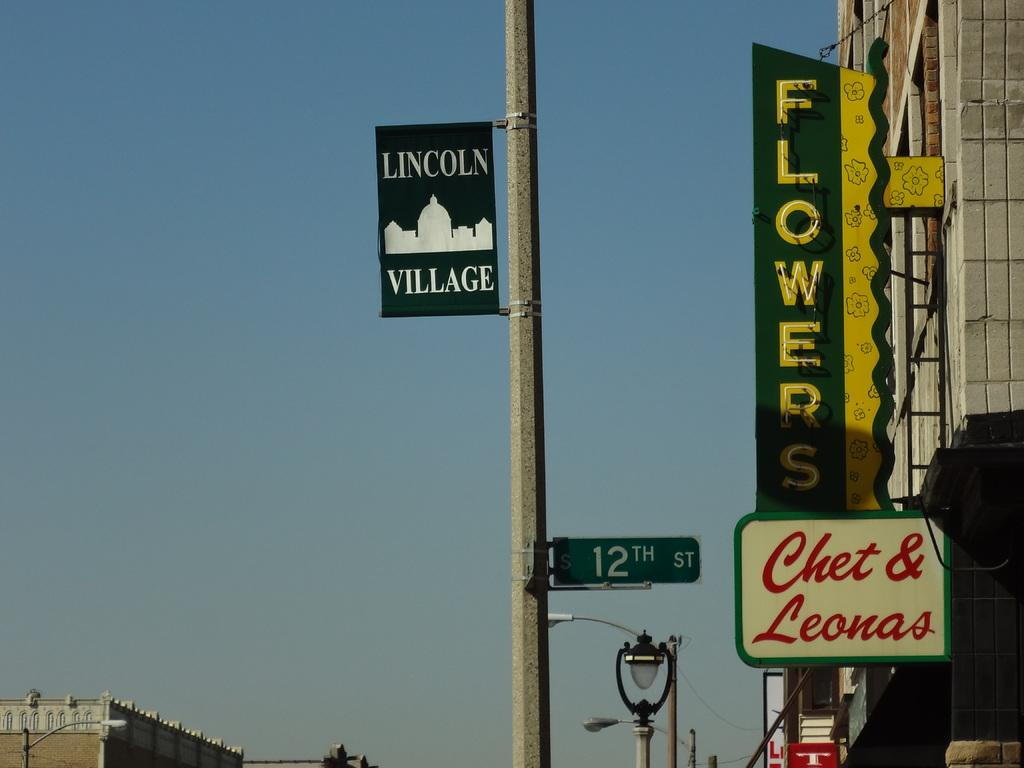<image>
Relay a brief, clear account of the picture shown. a flower store that is next to a pole 